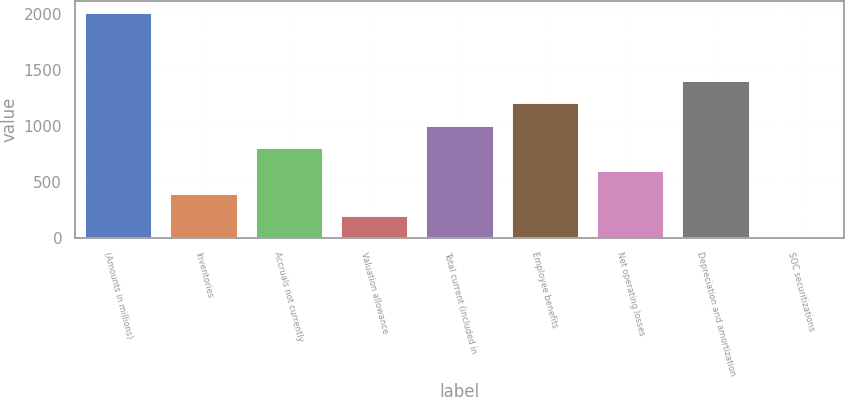Convert chart. <chart><loc_0><loc_0><loc_500><loc_500><bar_chart><fcel>(Amounts in millions)<fcel>Inventories<fcel>Accruals not currently<fcel>Valuation allowance<fcel>Total current (included in<fcel>Employee benefits<fcel>Net operating losses<fcel>Depreciation and amortization<fcel>SOC securitizations<nl><fcel>2012<fcel>402.72<fcel>805.04<fcel>201.56<fcel>1006.2<fcel>1207.36<fcel>603.88<fcel>1408.52<fcel>0.4<nl></chart> 